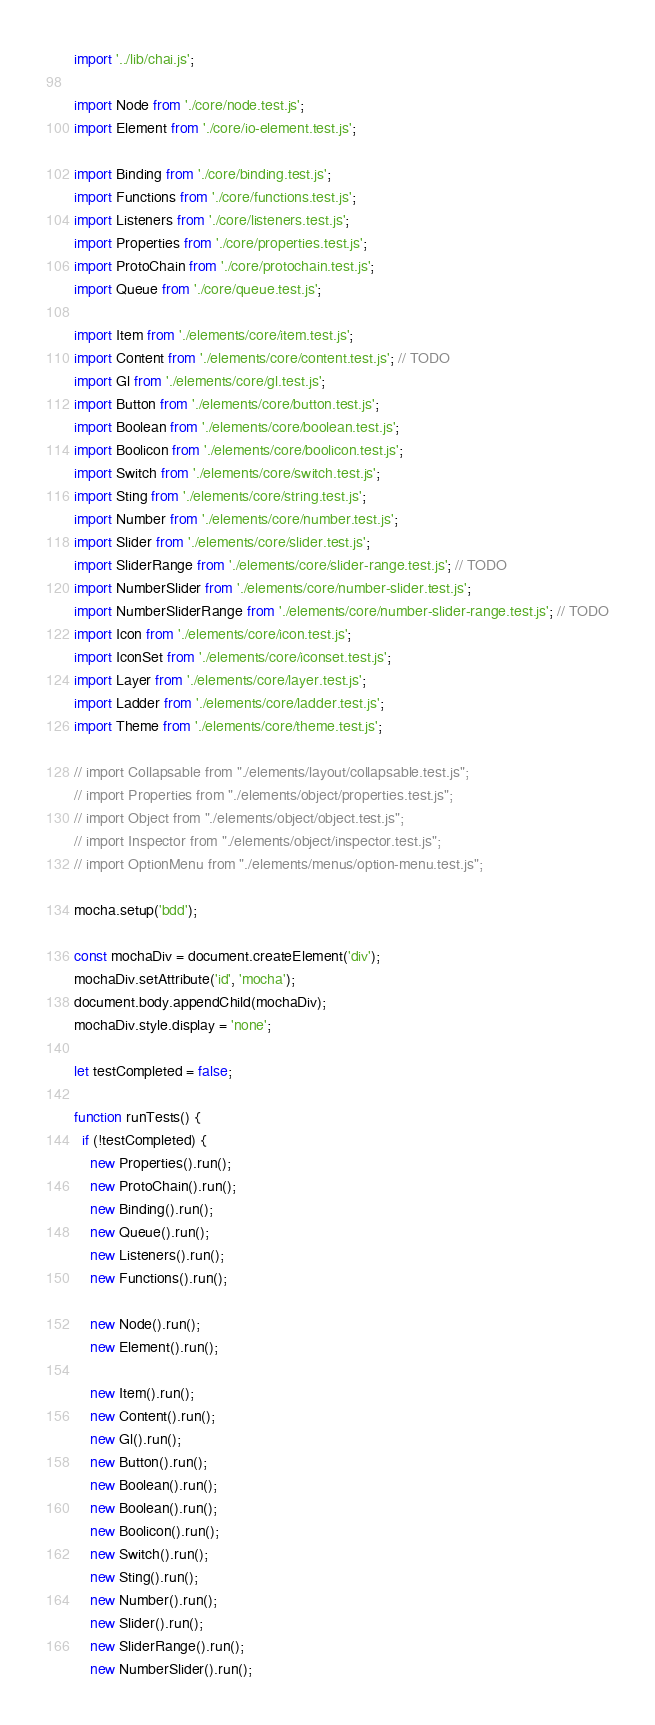<code> <loc_0><loc_0><loc_500><loc_500><_JavaScript_>import '../lib/chai.js';

import Node from './core/node.test.js';
import Element from './core/io-element.test.js';

import Binding from './core/binding.test.js';
import Functions from './core/functions.test.js';
import Listeners from './core/listeners.test.js';
import Properties from './core/properties.test.js';
import ProtoChain from './core/protochain.test.js';
import Queue from './core/queue.test.js';

import Item from './elements/core/item.test.js';
import Content from './elements/core/content.test.js'; // TODO
import Gl from './elements/core/gl.test.js';
import Button from './elements/core/button.test.js';
import Boolean from './elements/core/boolean.test.js';
import Boolicon from './elements/core/boolicon.test.js';
import Switch from './elements/core/switch.test.js';
import Sting from './elements/core/string.test.js';
import Number from './elements/core/number.test.js';
import Slider from './elements/core/slider.test.js';
import SliderRange from './elements/core/slider-range.test.js'; // TODO
import NumberSlider from './elements/core/number-slider.test.js';
import NumberSliderRange from './elements/core/number-slider-range.test.js'; // TODO
import Icon from './elements/core/icon.test.js';
import IconSet from './elements/core/iconset.test.js';
import Layer from './elements/core/layer.test.js';
import Ladder from './elements/core/ladder.test.js';
import Theme from './elements/core/theme.test.js';

// import Collapsable from "./elements/layout/collapsable.test.js";
// import Properties from "./elements/object/properties.test.js";
// import Object from "./elements/object/object.test.js";
// import Inspector from "./elements/object/inspector.test.js";
// import OptionMenu from "./elements/menus/option-menu.test.js";

mocha.setup('bdd');

const mochaDiv = document.createElement('div');
mochaDiv.setAttribute('id', 'mocha');
document.body.appendChild(mochaDiv);
mochaDiv.style.display = 'none';

let testCompleted = false;

function runTests() {
  if (!testCompleted) {
    new Properties().run();
    new ProtoChain().run();
    new Binding().run();
    new Queue().run();
    new Listeners().run();
    new Functions().run();

    new Node().run();
    new Element().run();

    new Item().run();
    new Content().run();
    new Gl().run();
    new Button().run();
    new Boolean().run();
    new Boolean().run();
    new Boolicon().run();
    new Switch().run();
    new Sting().run();
    new Number().run();
    new Slider().run();
    new SliderRange().run();
    new NumberSlider().run();</code> 